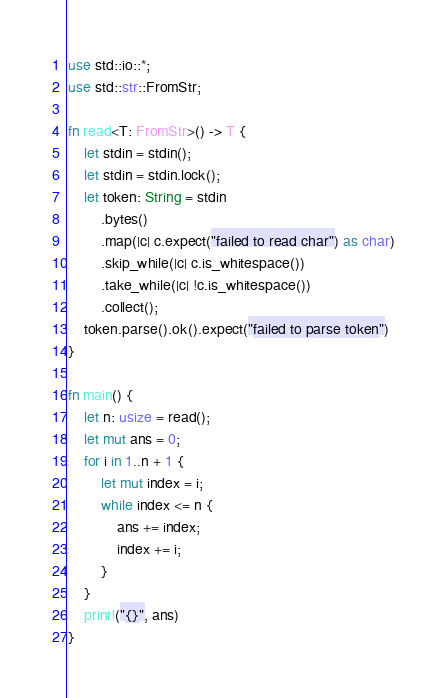Convert code to text. <code><loc_0><loc_0><loc_500><loc_500><_Rust_>use std::io::*;
use std::str::FromStr;

fn read<T: FromStr>() -> T {
    let stdin = stdin();
    let stdin = stdin.lock();
    let token: String = stdin
        .bytes()
        .map(|c| c.expect("failed to read char") as char)
        .skip_while(|c| c.is_whitespace())
        .take_while(|c| !c.is_whitespace())
        .collect();
    token.parse().ok().expect("failed to parse token")
}

fn main() {
    let n: usize = read();
    let mut ans = 0;
    for i in 1..n + 1 {
        let mut index = i;
        while index <= n {
            ans += index;
            index += i;
        }
    }
    print!("{}", ans)
}
</code> 